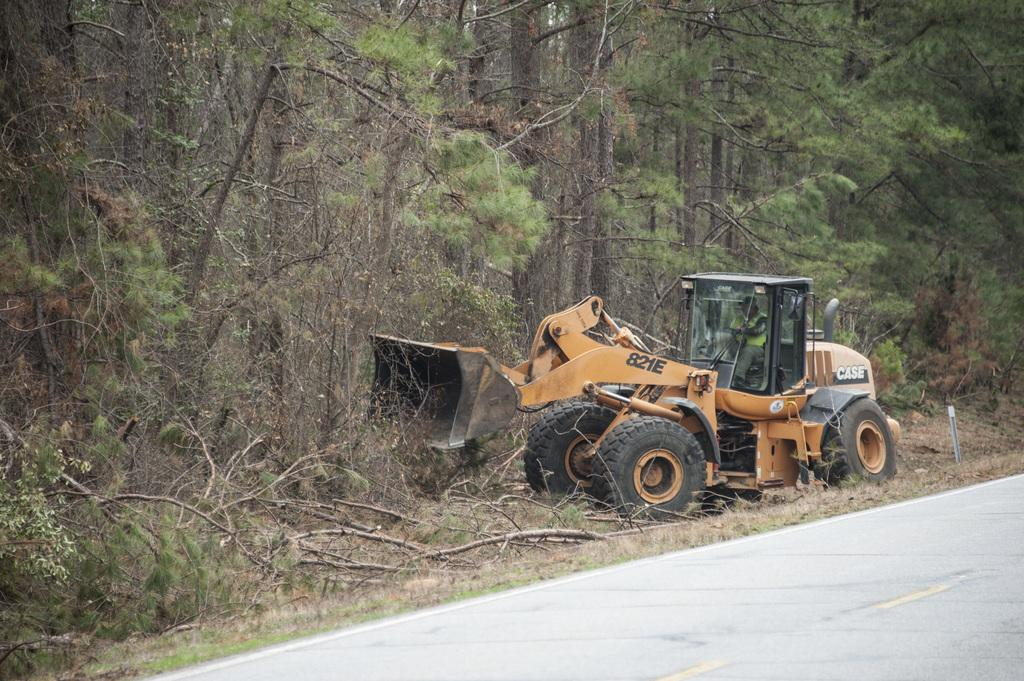<image>
Offer a succinct explanation of the picture presented. A bulldozer with the model number 821E on it's side. 